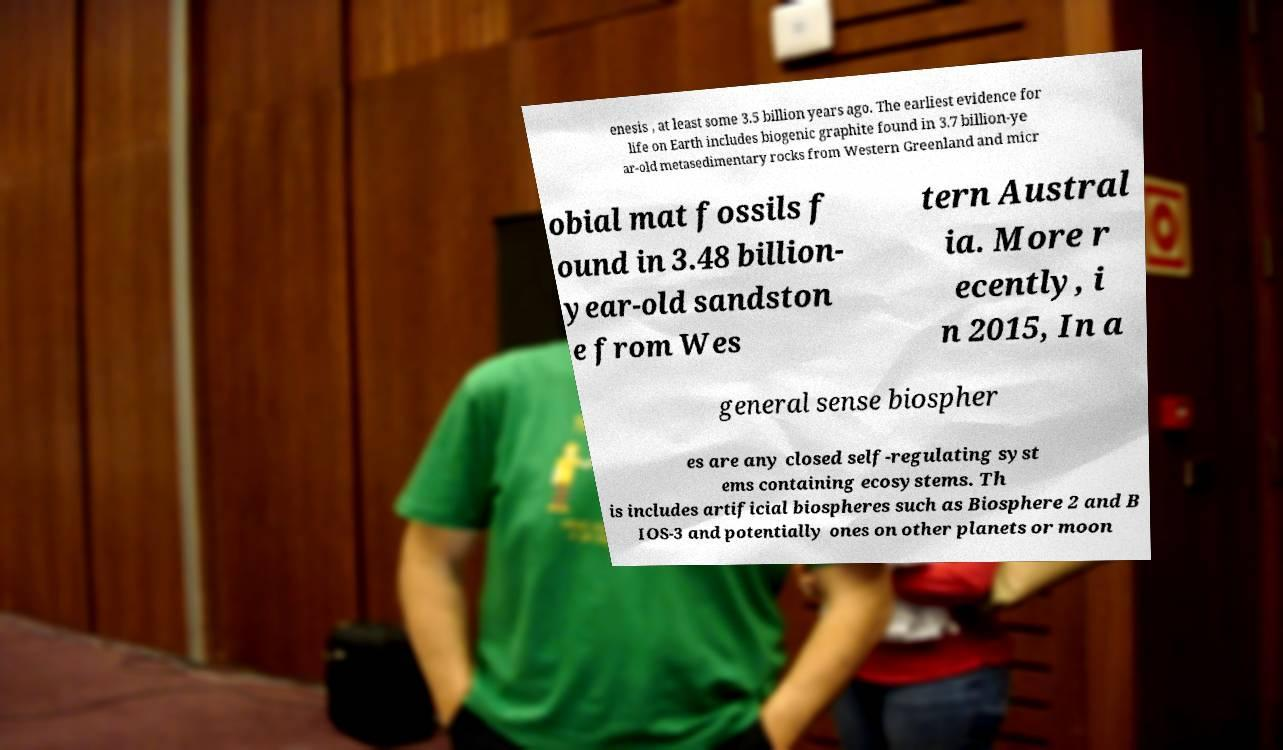There's text embedded in this image that I need extracted. Can you transcribe it verbatim? enesis , at least some 3.5 billion years ago. The earliest evidence for life on Earth includes biogenic graphite found in 3.7 billion-ye ar-old metasedimentary rocks from Western Greenland and micr obial mat fossils f ound in 3.48 billion- year-old sandston e from Wes tern Austral ia. More r ecently, i n 2015, In a general sense biospher es are any closed self-regulating syst ems containing ecosystems. Th is includes artificial biospheres such as Biosphere 2 and B IOS-3 and potentially ones on other planets or moon 